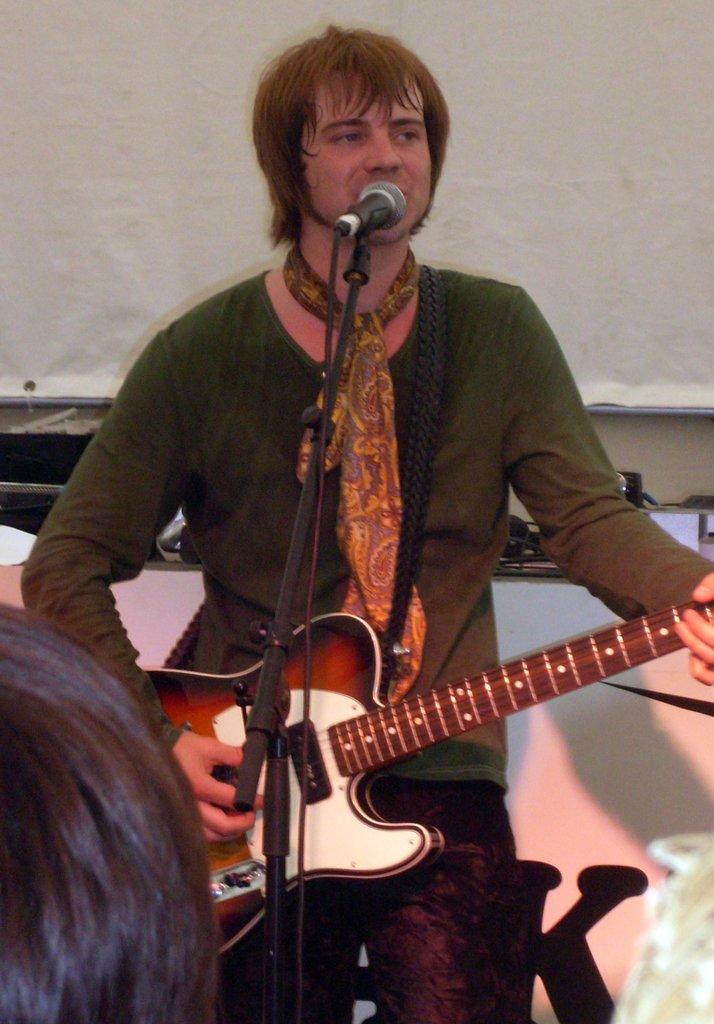What is the man in the image doing? The man is playing a guitar. How is the man holding the guitar? The man is holding the guitar in his hands. What is in front of the man that he might use for amplifying his voice? There is a microphone in front of the man. What is the man standing in front of? There is a stand in front of the man. What can be seen in the background of the image? There is a wall in the background of the image. What type of brass instrument is the man playing in the image? The man is not playing a brass instrument in the image; he is playing a guitar. What is the man's income based on his performance in the image? There is no information about the man's income in the image. 